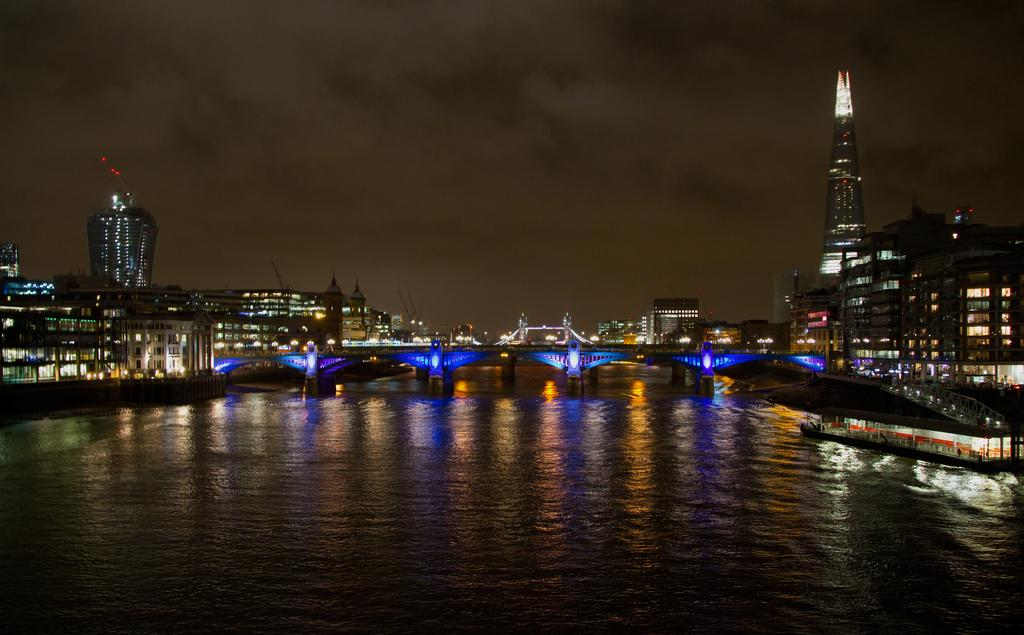What is the main structure in the center of the image? There is a bridge in the center of the image. What can be seen in the water near the bridge? There is a ship in the water. What type of structures can be seen in the background of the image? There are buildings in the background of the image. What else can be seen in the background of the image? There are lights in the background of the image. What is visible at the top of the image? The sky is visible at the top of the image. Where are the kittens being treated for coal-related illnesses in the image? There are no kittens or coal-related illnesses present in the image. 